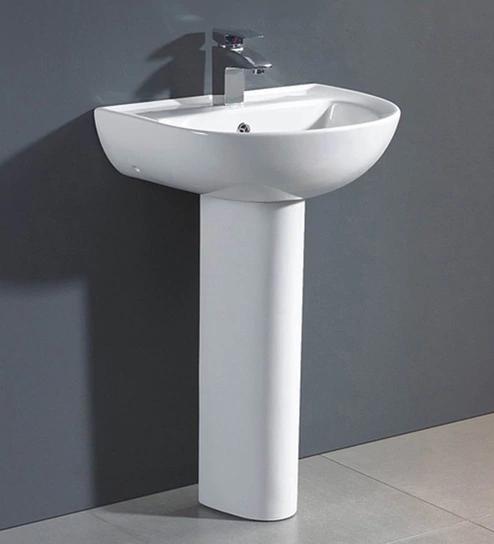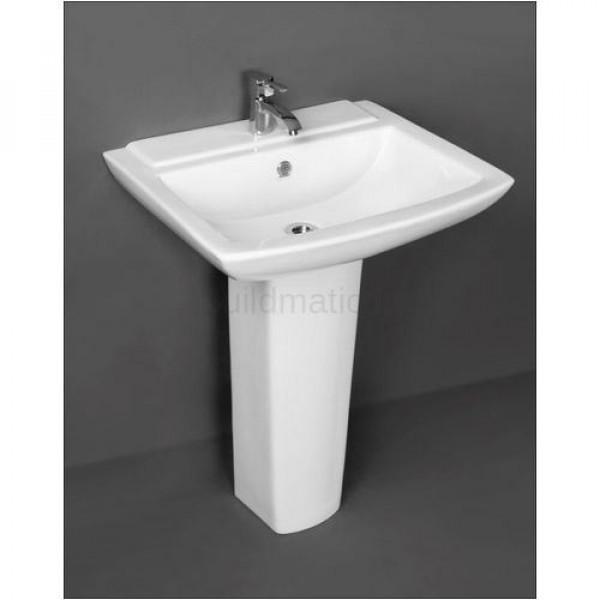The first image is the image on the left, the second image is the image on the right. Examine the images to the left and right. Is the description "The image on the right has a plain white background." accurate? Answer yes or no. No. 